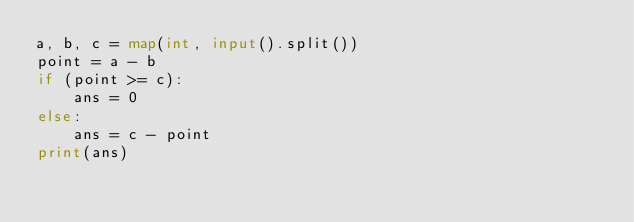Convert code to text. <code><loc_0><loc_0><loc_500><loc_500><_Python_>a, b, c = map(int, input().split())
point = a - b
if (point >= c):
    ans = 0
else:
    ans = c - point
print(ans)</code> 